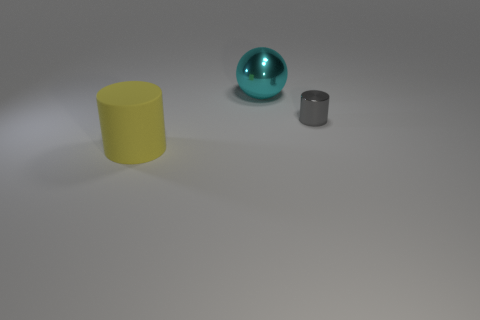Add 1 large things. How many objects exist? 4 Subtract all purple cylinders. Subtract all blue spheres. How many cylinders are left? 2 Subtract all balls. How many objects are left? 2 Subtract 0 blue cubes. How many objects are left? 3 Subtract all metallic cylinders. Subtract all big cyan spheres. How many objects are left? 1 Add 3 small things. How many small things are left? 4 Add 2 small blue metal objects. How many small blue metal objects exist? 2 